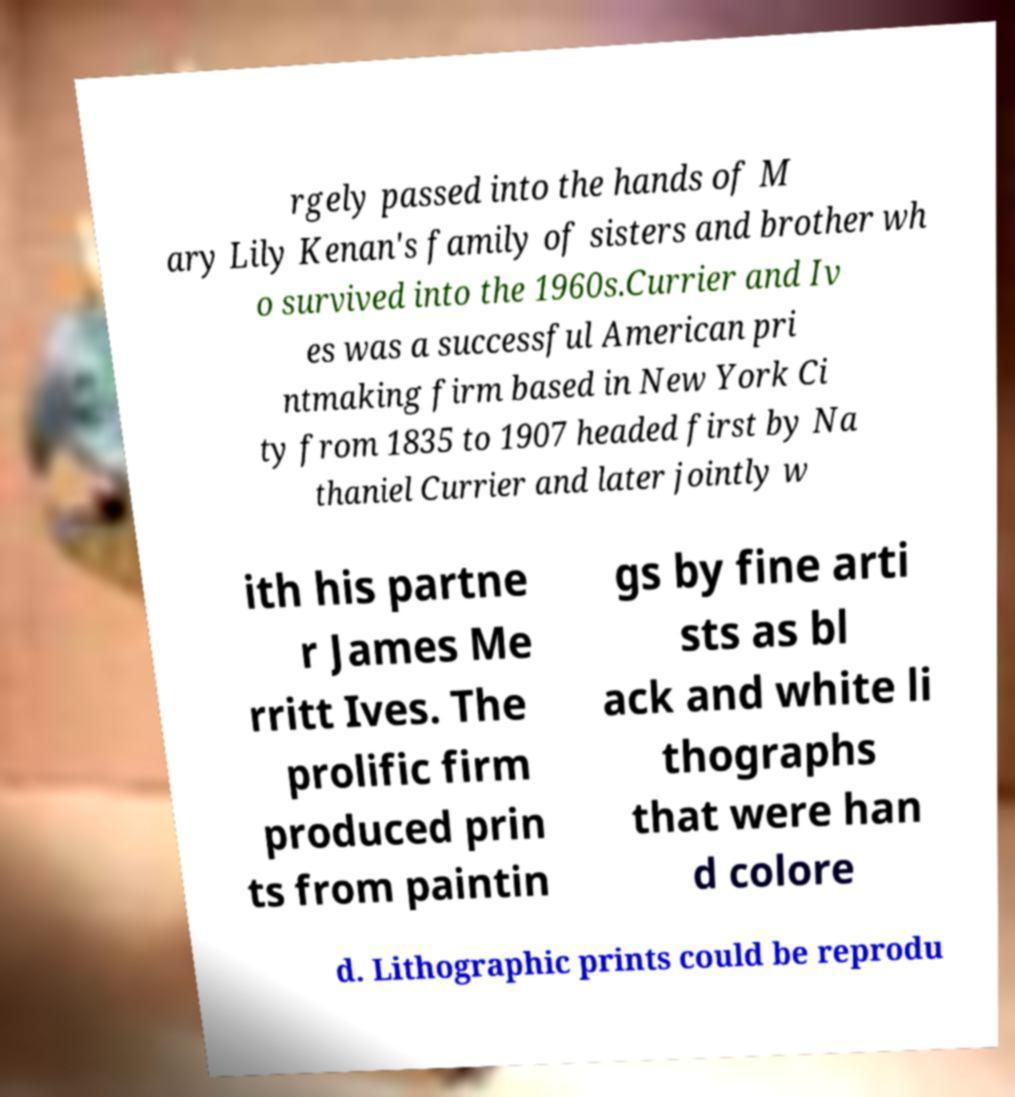Could you assist in decoding the text presented in this image and type it out clearly? rgely passed into the hands of M ary Lily Kenan's family of sisters and brother wh o survived into the 1960s.Currier and Iv es was a successful American pri ntmaking firm based in New York Ci ty from 1835 to 1907 headed first by Na thaniel Currier and later jointly w ith his partne r James Me rritt Ives. The prolific firm produced prin ts from paintin gs by fine arti sts as bl ack and white li thographs that were han d colore d. Lithographic prints could be reprodu 